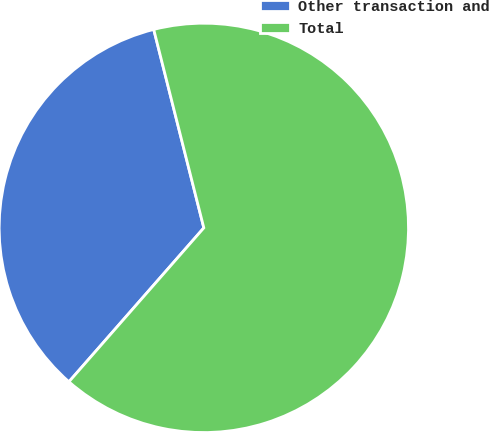Convert chart. <chart><loc_0><loc_0><loc_500><loc_500><pie_chart><fcel>Other transaction and<fcel>Total<nl><fcel>34.61%<fcel>65.39%<nl></chart> 